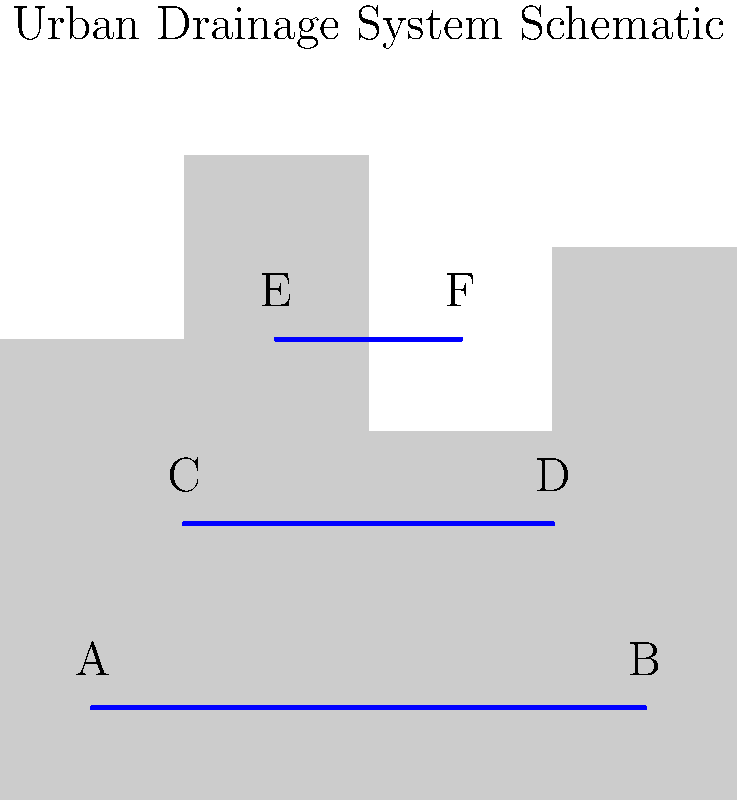In the schematic representation of an urban drainage system, three levels of water flow are depicted. How might this hierarchical structure of water flow relate to the concept of narrative layers in literature, and what implications does this have for the efficiency of both storytelling and urban water management? To answer this question, we need to analyze the schematic drawing and draw parallels between the urban drainage system and storytelling structures:

1. Observe the three levels of water flow:
   - Bottom level: A to B
   - Middle level: C to D
   - Top level: E to F

2. Consider the hierarchical structure:
   - The bottom level represents the main flow, similar to the main plot in a story.
   - The middle and top levels are secondary flows, akin to subplots or character arcs.

3. Analyze the efficiency of the system:
   - Water flows from higher to lower levels, integrating into the main flow.
   - This mimics how subplots and character development contribute to the main narrative.

4. Implications for storytelling:
   - Multiple narrative layers can enrich the overall story, just as multiple drainage levels enhance water management.
   - The integration of subplots (secondary flows) into the main plot (primary flow) creates a cohesive narrative structure.

5. Implications for urban water management:
   - Hierarchical systems allow for better control and distribution of water flow.
   - Secondary channels can alleviate pressure on the main channel during high-flow events.

6. Shared concepts:
   - Both systems rely on effective flow and integration of elements.
   - Complexity is managed through hierarchical structures.
   - The ultimate goal is a smooth, efficient progression (of water or narrative).

This analysis demonstrates how the principles of efficient water flow in urban drainage systems can be metaphorically applied to the structure and flow of narrative in literature, highlighting the universality of hierarchical systems in both engineering and storytelling.
Answer: Hierarchical flow structures in both drainage systems and storytelling enhance efficiency and depth through the integration of multiple levels. 